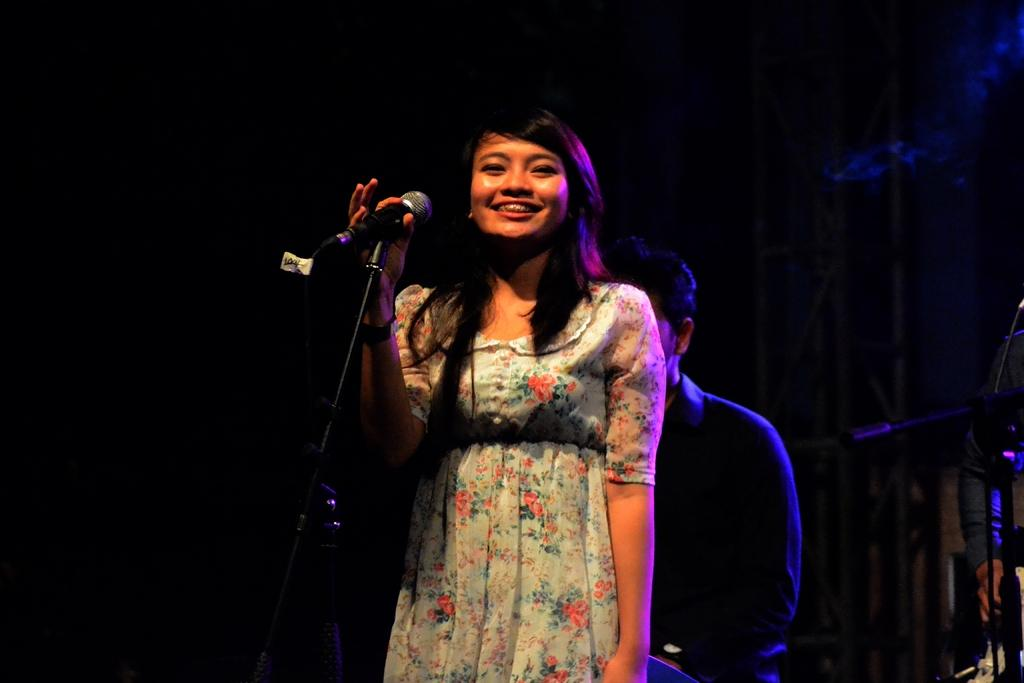What is the woman in the image doing? The woman is standing in the middle of the image and smiling. What is the woman holding in the image? The woman is holding a microphone. Can you describe the person behind the woman? There is a man behind the woman. Where is the person located in the image? There is a person standing in the bottom right side of the image. What type of reward is the woman receiving for her crime in the image? There is no indication of a crime or reward in the image; the woman is simply standing and holding a microphone. 